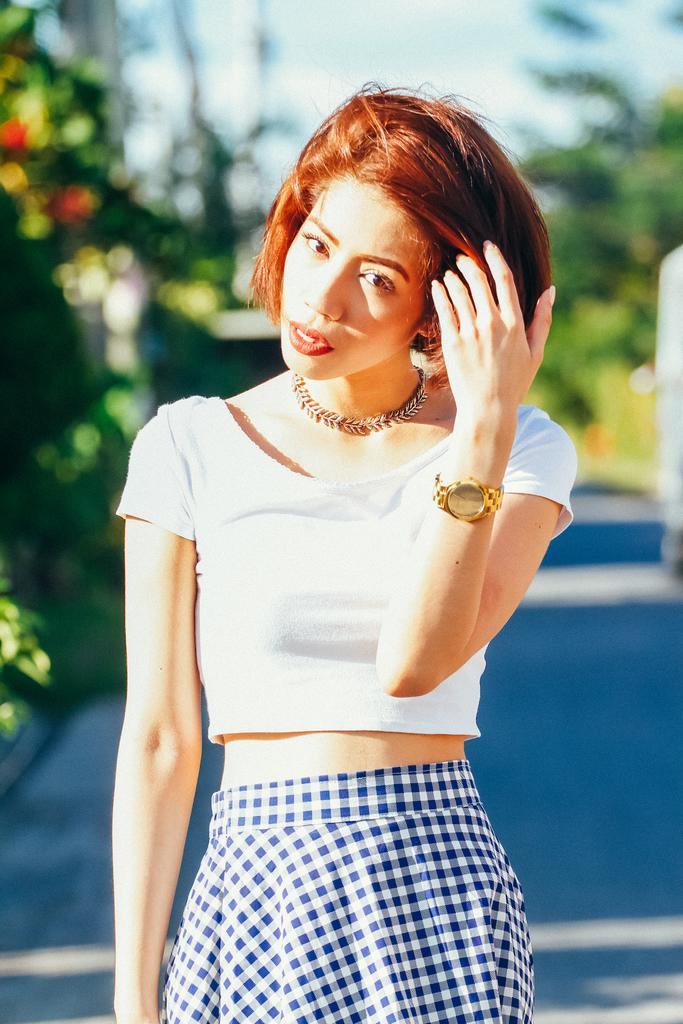Who or what is the main subject of the image? There is a person in the image. What can be observed about the background of the image? The background of the image is blurred. What is the person in the image wearing? The person is wearing clothes. Can you identify any accessories the person is wearing? The person is wearing a watch. How many visitors are present in the image? There is no mention of visitors in the image; it features a person with a blurred background. What type of battle is taking place in the image? There is no battle present in the image; it features a person wearing clothes and a watch. 